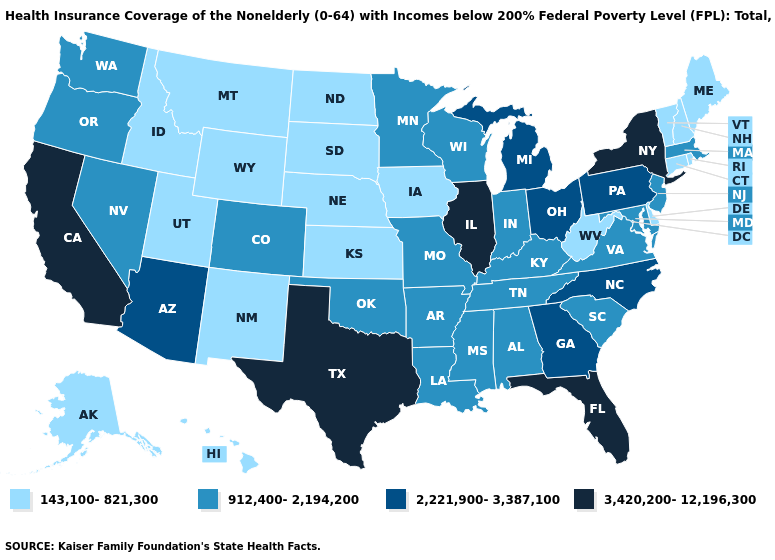What is the lowest value in the USA?
Give a very brief answer. 143,100-821,300. What is the highest value in the USA?
Concise answer only. 3,420,200-12,196,300. What is the value of Nevada?
Write a very short answer. 912,400-2,194,200. Name the states that have a value in the range 3,420,200-12,196,300?
Keep it brief. California, Florida, Illinois, New York, Texas. Name the states that have a value in the range 143,100-821,300?
Write a very short answer. Alaska, Connecticut, Delaware, Hawaii, Idaho, Iowa, Kansas, Maine, Montana, Nebraska, New Hampshire, New Mexico, North Dakota, Rhode Island, South Dakota, Utah, Vermont, West Virginia, Wyoming. What is the value of New Mexico?
Keep it brief. 143,100-821,300. Name the states that have a value in the range 3,420,200-12,196,300?
Short answer required. California, Florida, Illinois, New York, Texas. What is the value of Connecticut?
Quick response, please. 143,100-821,300. Which states hav the highest value in the MidWest?
Keep it brief. Illinois. Does Kentucky have the lowest value in the South?
Answer briefly. No. Name the states that have a value in the range 143,100-821,300?
Write a very short answer. Alaska, Connecticut, Delaware, Hawaii, Idaho, Iowa, Kansas, Maine, Montana, Nebraska, New Hampshire, New Mexico, North Dakota, Rhode Island, South Dakota, Utah, Vermont, West Virginia, Wyoming. Name the states that have a value in the range 912,400-2,194,200?
Be succinct. Alabama, Arkansas, Colorado, Indiana, Kentucky, Louisiana, Maryland, Massachusetts, Minnesota, Mississippi, Missouri, Nevada, New Jersey, Oklahoma, Oregon, South Carolina, Tennessee, Virginia, Washington, Wisconsin. Among the states that border Oregon , which have the lowest value?
Concise answer only. Idaho. Which states have the highest value in the USA?
Write a very short answer. California, Florida, Illinois, New York, Texas. Which states have the lowest value in the USA?
Quick response, please. Alaska, Connecticut, Delaware, Hawaii, Idaho, Iowa, Kansas, Maine, Montana, Nebraska, New Hampshire, New Mexico, North Dakota, Rhode Island, South Dakota, Utah, Vermont, West Virginia, Wyoming. 